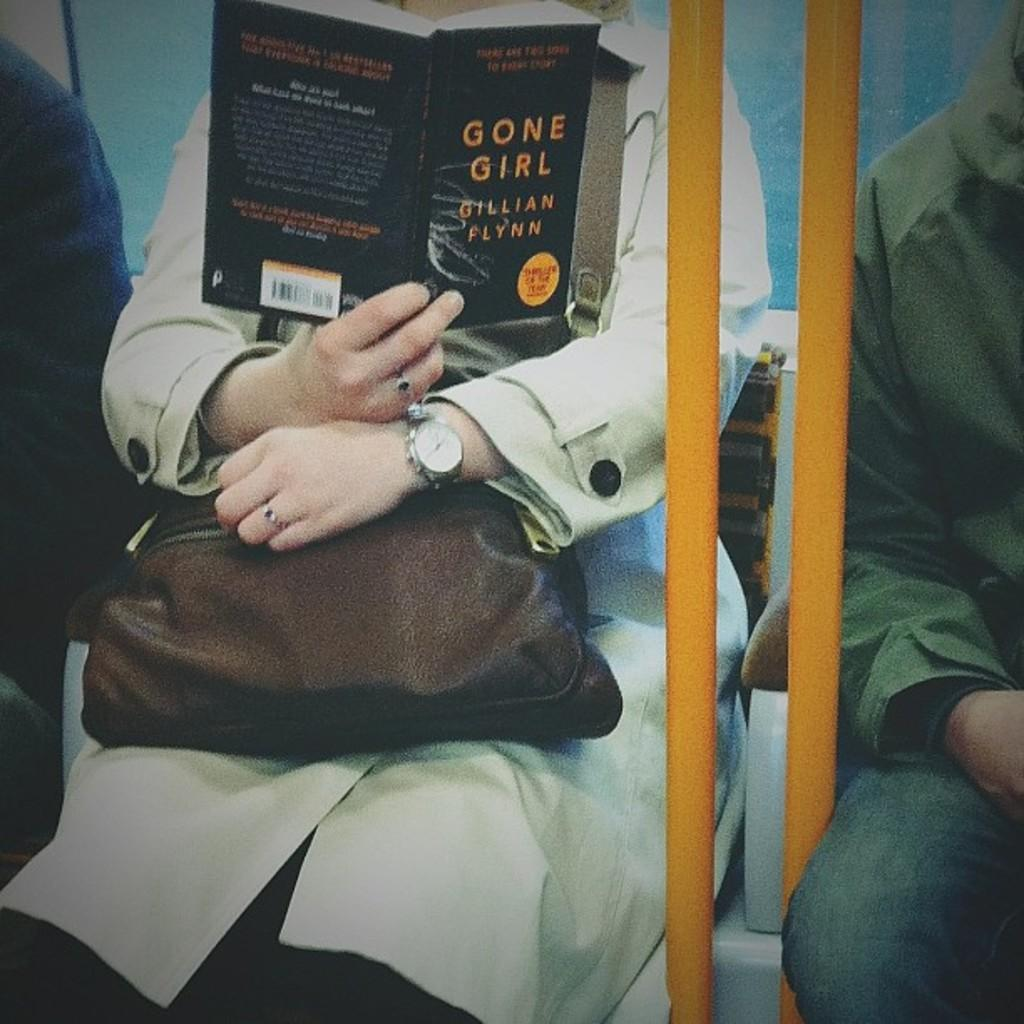<image>
Describe the image concisely. A woman on a subway reads Gone Girl by Gillian Flynn while she holds her purse. 